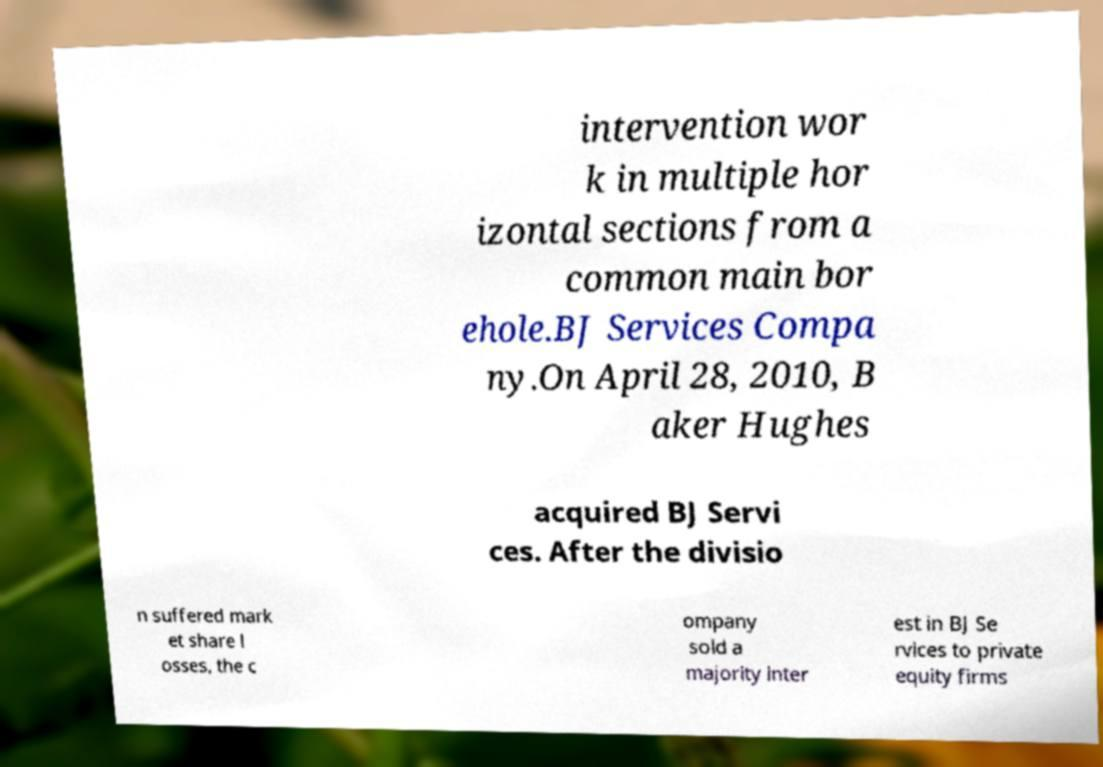Can you read and provide the text displayed in the image?This photo seems to have some interesting text. Can you extract and type it out for me? intervention wor k in multiple hor izontal sections from a common main bor ehole.BJ Services Compa ny.On April 28, 2010, B aker Hughes acquired BJ Servi ces. After the divisio n suffered mark et share l osses, the c ompany sold a majority inter est in BJ Se rvices to private equity firms 